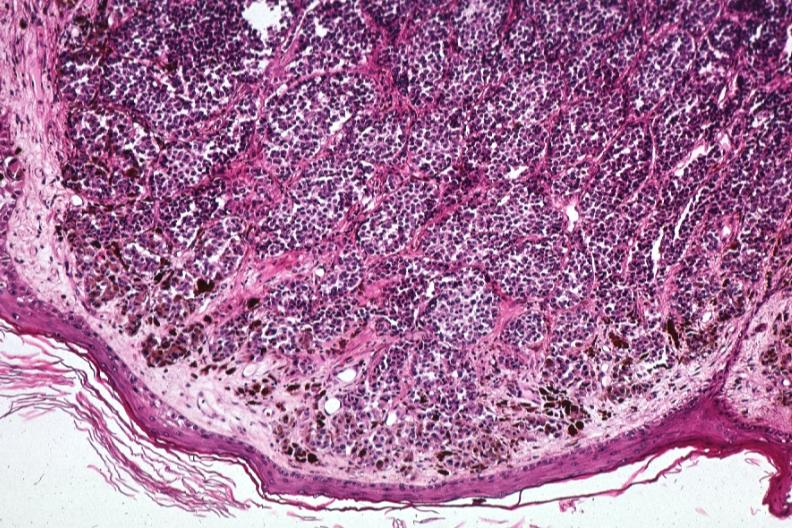re fibrosis mumps same lesion?
Answer the question using a single word or phrase. No 